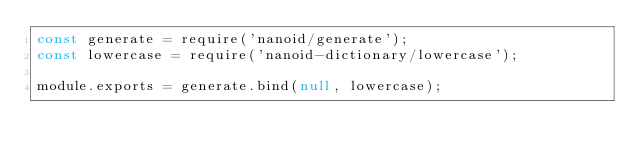<code> <loc_0><loc_0><loc_500><loc_500><_JavaScript_>const generate = require('nanoid/generate');
const lowercase = require('nanoid-dictionary/lowercase');

module.exports = generate.bind(null, lowercase);</code> 